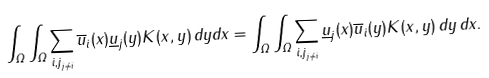<formula> <loc_0><loc_0><loc_500><loc_500>\int _ { \Omega } \int _ { \Omega } \sum _ { { i , j } _ { j \neq i } } \overline { u } _ { i } ( x ) \underline { u } _ { j } ( y ) K ( x , y ) \, d y d x = \int _ { \Omega } \int _ { \Omega } \sum _ { { i , j } _ { j \neq i } } \underline { u } _ { j } ( x ) \overline { u } _ { i } ( y ) K ( x , y ) \, d y \, d x .</formula> 